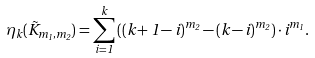Convert formula to latex. <formula><loc_0><loc_0><loc_500><loc_500>\eta _ { k } ( \vec { K } _ { m _ { 1 } , m _ { 2 } } ) = \sum _ { i = 1 } ^ { k } { \left ( ( k + 1 - i ) ^ { m _ { 2 } } - ( k - i ) ^ { m _ { 2 } } \right ) \cdot i ^ { m _ { 1 } } } .</formula> 